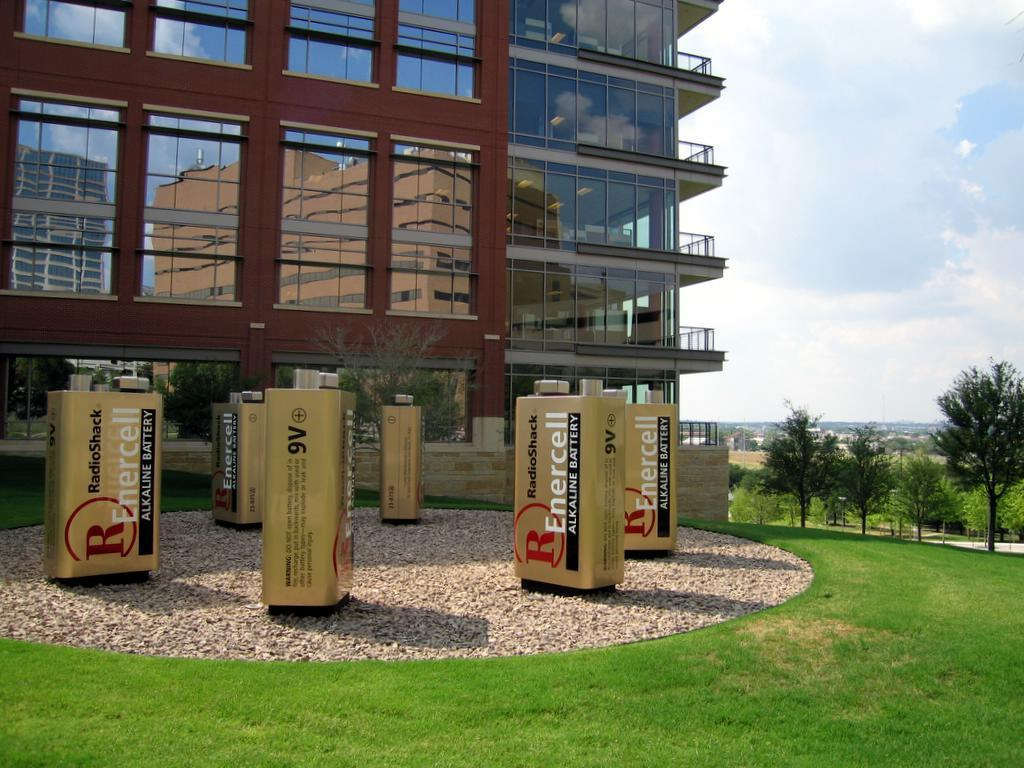What can be found in the middle of the garden in the image? There are battery structures models in the middle of the garden. What type of natural elements can be seen in the background of the image? There are trees in the background of the image. What man-made structures are visible in the background of the image? There are buildings in the background of the image. What is the condition of the sky in the image? Clouds are present in the background of the image. What type of vase can be seen holding the clam in the image? There is no vase or clam present in the image. How is the butter being used in the image? There is no butter present in the image. 